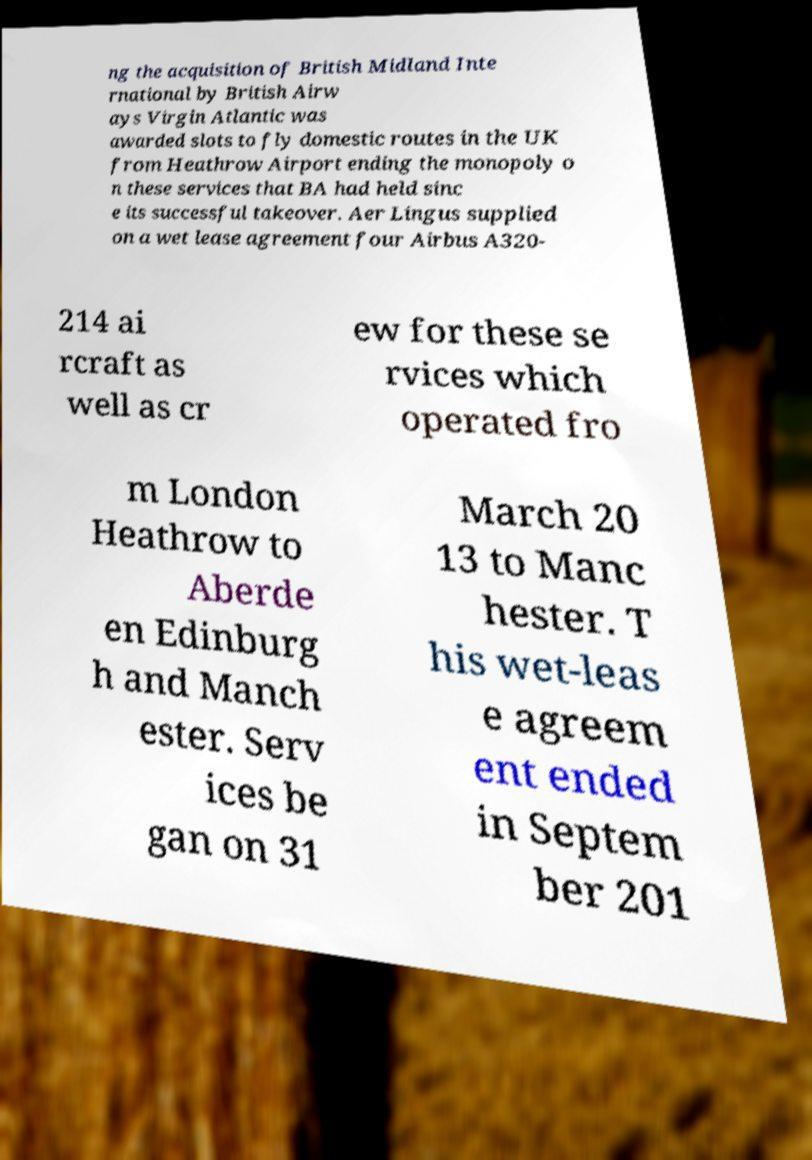For documentation purposes, I need the text within this image transcribed. Could you provide that? ng the acquisition of British Midland Inte rnational by British Airw ays Virgin Atlantic was awarded slots to fly domestic routes in the UK from Heathrow Airport ending the monopoly o n these services that BA had held sinc e its successful takeover. Aer Lingus supplied on a wet lease agreement four Airbus A320- 214 ai rcraft as well as cr ew for these se rvices which operated fro m London Heathrow to Aberde en Edinburg h and Manch ester. Serv ices be gan on 31 March 20 13 to Manc hester. T his wet-leas e agreem ent ended in Septem ber 201 